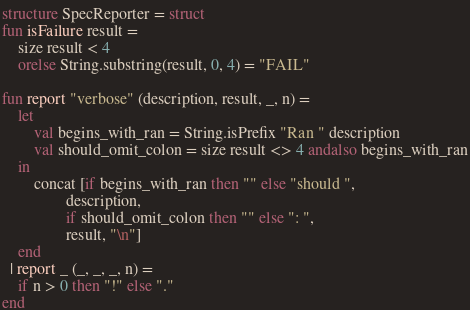<code> <loc_0><loc_0><loc_500><loc_500><_SML_>structure SpecReporter = struct
fun isFailure result =
    size result < 4
    orelse String.substring(result, 0, 4) = "FAIL"

fun report "verbose" (description, result, _, n) =
    let
        val begins_with_ran = String.isPrefix "Ran " description
        val should_omit_colon = size result <> 4 andalso begins_with_ran
    in
        concat [if begins_with_ran then "" else "should ",
                description,
                if should_omit_colon then "" else ": ",
                result, "\n"]
    end
  | report _ (_, _, _, n) =
    if n > 0 then "!" else "."
end
</code> 